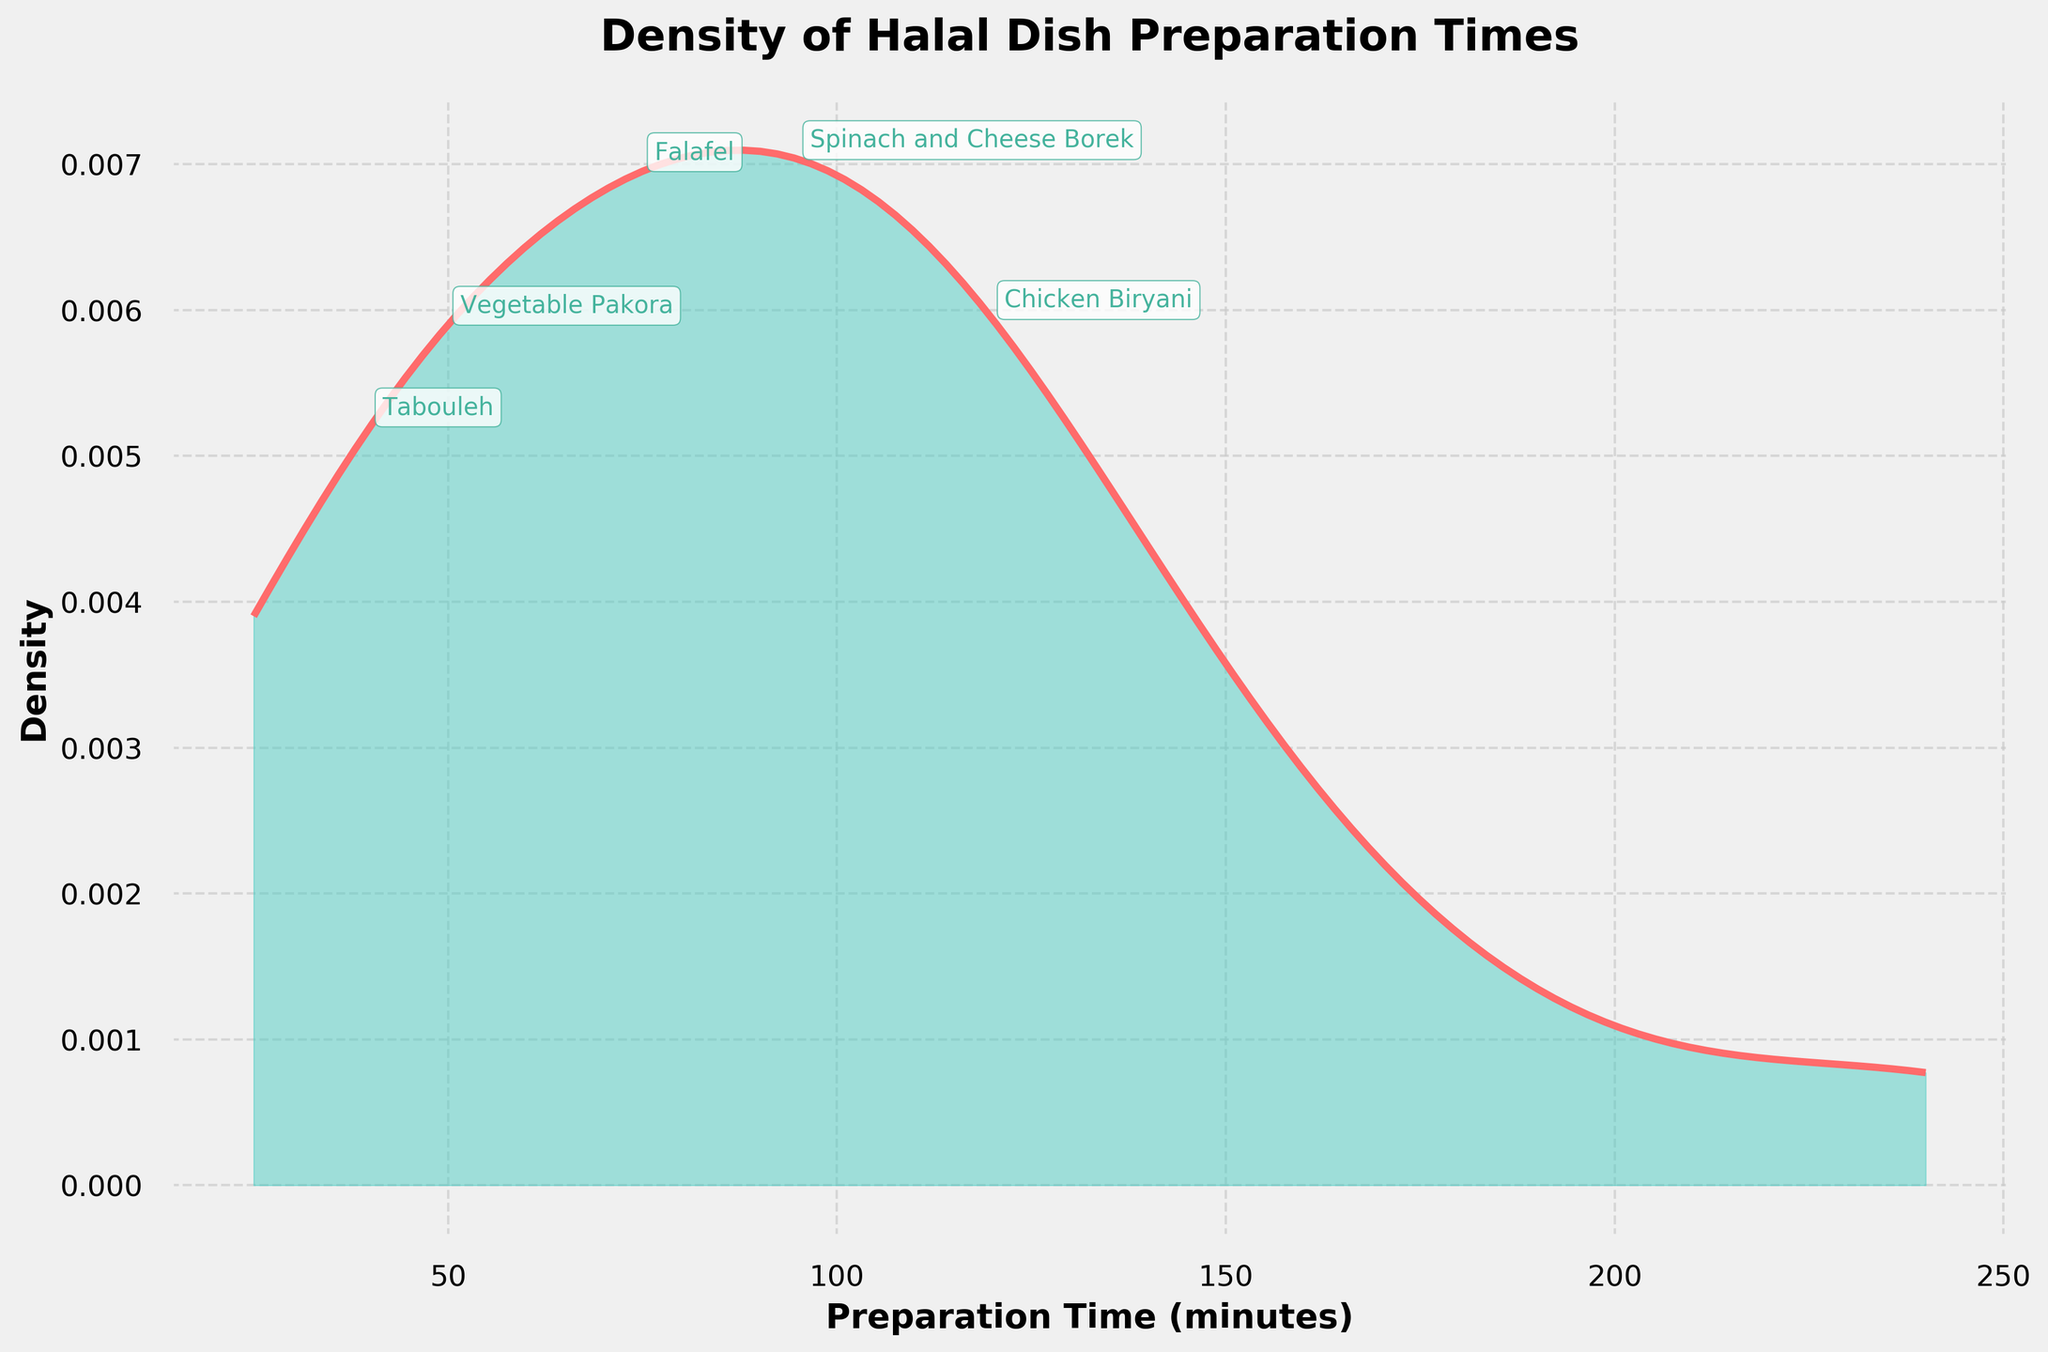What is the title of the density plot? The title of the density plot is usually located at the top of the figure and describes the subject of the visualization. Here, it reads 'Density of Halal Dish Preparation Times'.
Answer: Density of Halal Dish Preparation Times What information does the y-axis represent? By examining the label on the y-axis, it indicates that it represents the 'Density' of the data points. This shows how preparation times are distributed.
Answer: Density Which dish has the shortest preparation time? By looking at the text annotations closest to the y-axis and the lowest x-axis value, the dish is 'Fattoush Salad' with a preparation time of 25 minutes.
Answer: Fattoush Salad Which dish takes the longest time to prepare? The dish with the longest preparation time will be annotated at the highest x-axis value. It's 'Haleem' with a preparation time of 240 minutes.
Answer: Haleem Which range of preparation times has the highest density? Observing the density plot, the peak or highest point indicates the highest density. This peak appears between 50 and 100 minutes.
Answer: 50 to 100 minutes How many dishes have preparation times over 150 minutes? By identifying the text annotations on the right side of 150 minutes on the x-axis, there are Baklava (180), Haleem (240), and Beef Shawarma (150).
Answer: 3 dishes What can be said about the spread of preparation times for halal dishes based on the density plot? The wide spread of the density plot, with peaks and varying density values across different preparation times, indicates a significant variation in how long it takes to prepare different halal dishes.
Answer: Significant variation Which dish falls within the preparation time range where the density is highest? The peak density range is between 50 and 100 minutes. Dishes like Vegetable Samosas (60), Falafel (75), and Spinach and Cheese Borek (95) fall within this range.
Answer: Vegetable Samosas, Falafel, and Spinach and Cheese Borek What preparation time does the density peak correspond to? The peak of the density plot corresponds to the highest concentration of preparation times, around 75 minutes.
Answer: Around 75 minutes 